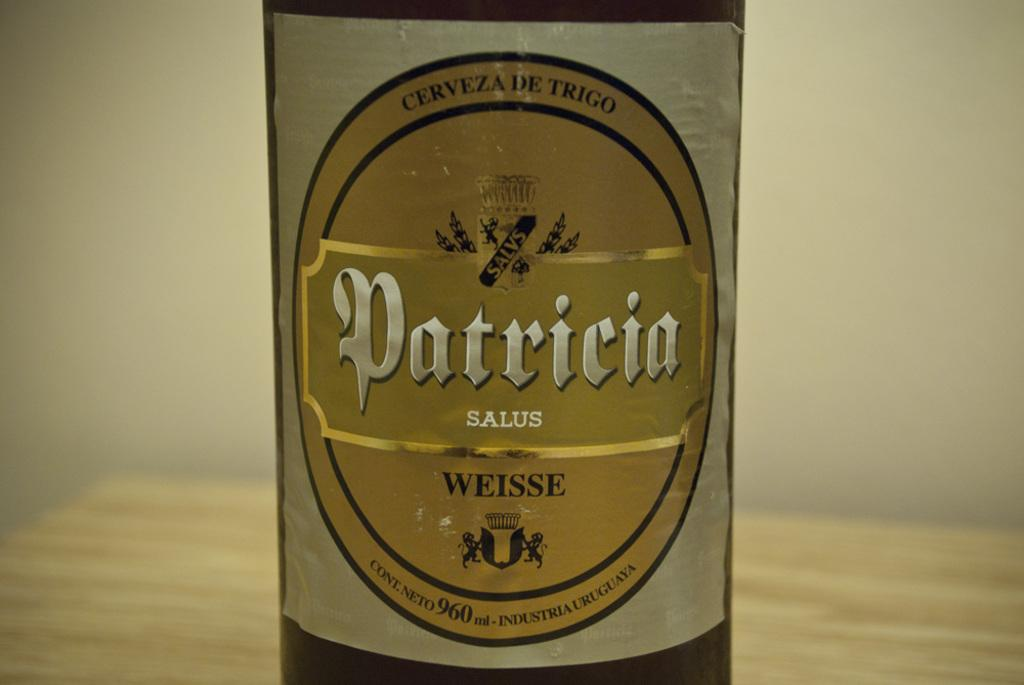<image>
Relay a brief, clear account of the picture shown. The female name Patricia is also the name of a brand of imported beer. 